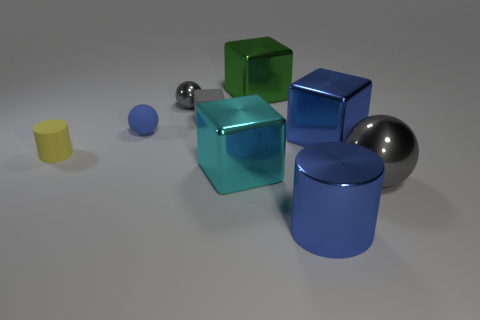Subtract all spheres. How many objects are left? 6 Add 1 tiny green cubes. How many tiny green cubes exist? 1 Subtract 0 cyan cylinders. How many objects are left? 9 Subtract all purple cylinders. Subtract all tiny gray things. How many objects are left? 7 Add 6 big cylinders. How many big cylinders are left? 7 